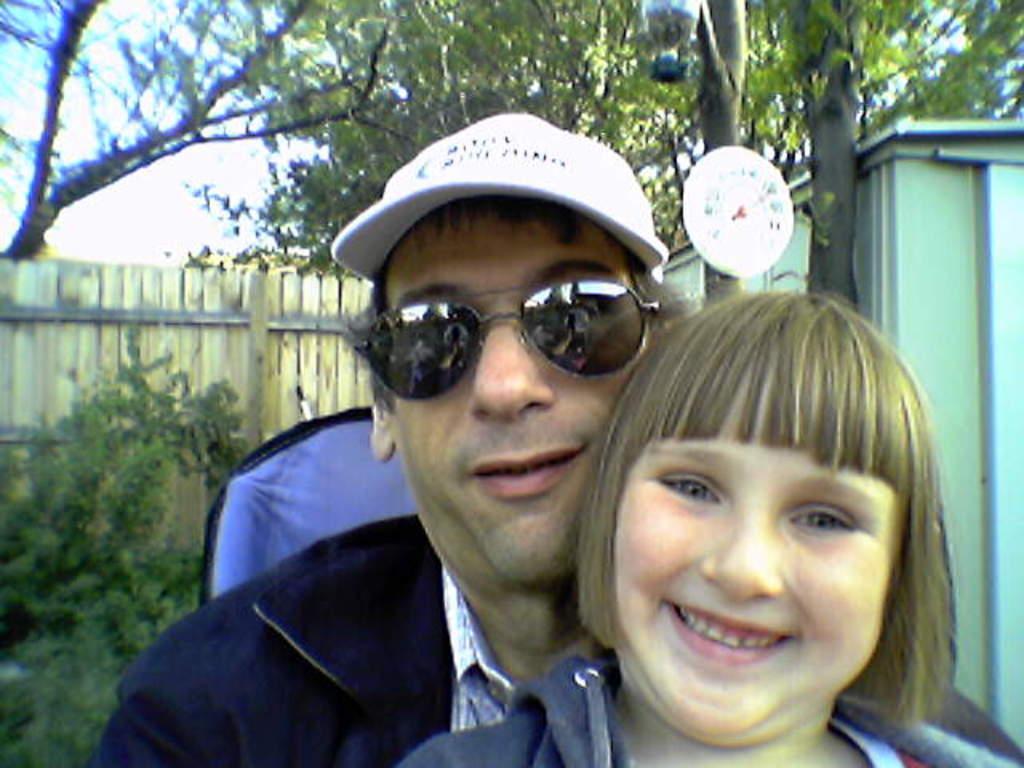In one or two sentences, can you explain what this image depicts? In the center of the image, we can see people and one of them is wearing glasses and a cap. In the background, there are trees, a fence, board and a shed. 